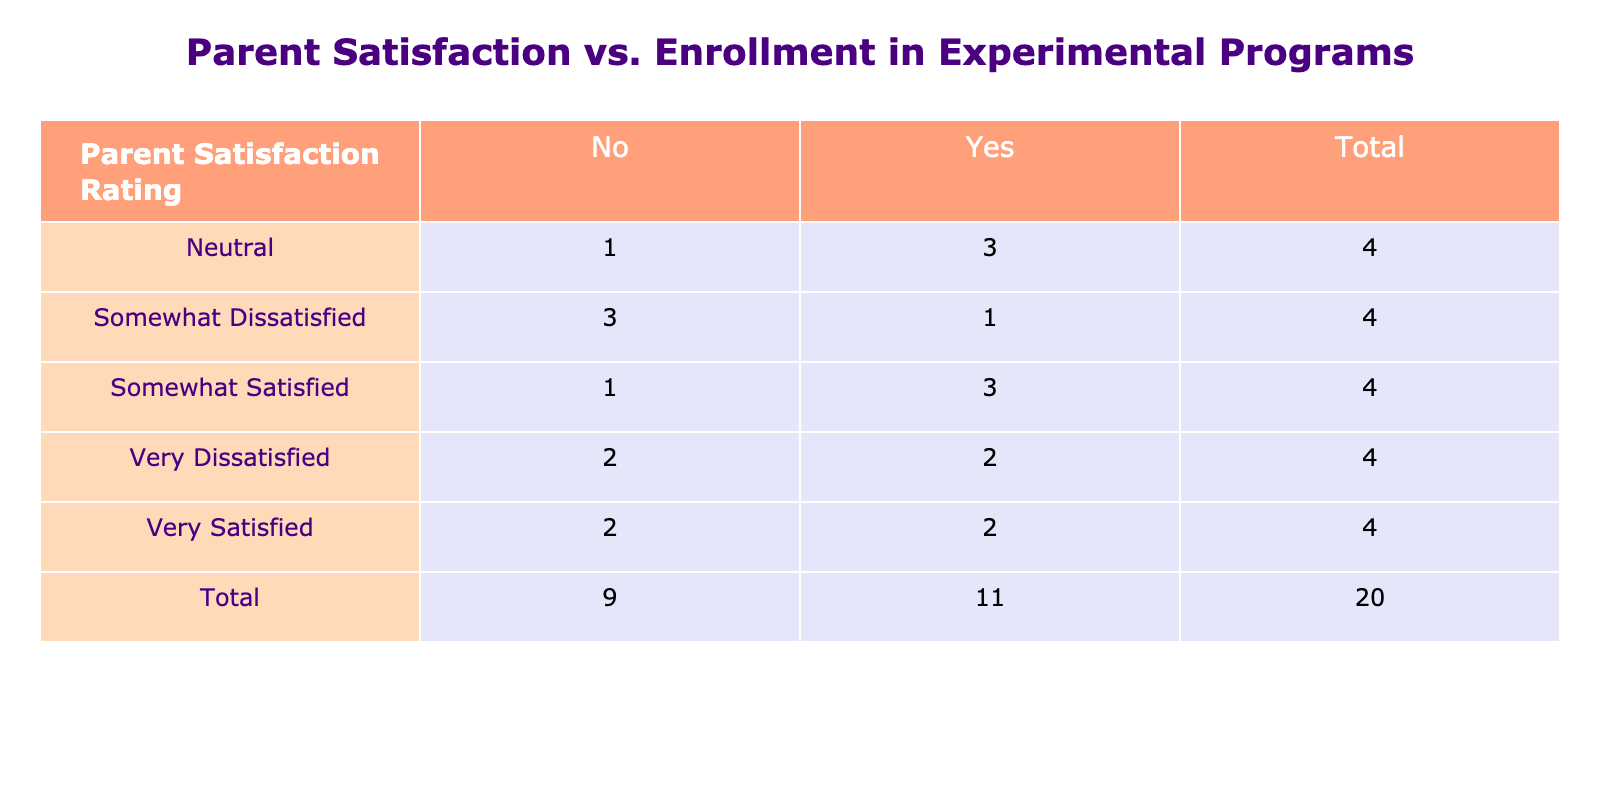What is the total number of parents that were very satisfied with their child's education in experimental programs? From the table, we can see that there are 4 parents who reported being "Very Satisfied" with their child's education, 3 of whom are enrolled in the experimental program and 1 who is not. Therefore, the total number of parents who are very satisfied is 4.
Answer: 4 How many parents were somewhat dissatisfied and did not enroll in experimental education programs? Referring to the table, we can find that there are 3 parents who reported being "Somewhat Dissatisfied", and out of these, 2 did not enroll in the experimental program.
Answer: 2 What percentage of parents are very satisfied with their child's education? In the table, there are 4 parents who are very satisfied, and the grand total of parent satisfaction ratings is 20. To find the percentage, we calculate (4/20) * 100 = 20%.
Answer: 20% Is it true that a majority of parents who enrolled in the experimental program reported being satisfied? Looking at the table, we can see that 11 parents enrolled in the experimental program (Sum of "Very Satisfied", "Somewhat Satisfied", "Neutral", and "Somewhat Dissatisfied" when enrolled). Out of these, at least 6 parents are either "Very Satisfied" or "Somewhat Satisfied”. Since 6 out of 11 represents more than half (54.5%), the statement is true.
Answer: Yes How many total parents expressed neutrality about their child's education in experimental programs? The table shows that there are 4 parents who reported being "Neutral”. Out of these, 3 are enrolled in the experimental program and 1 is not. So, the total number of parents expressing neutrality is 4.
Answer: 4 What is the difference in the number of very dissatisfied parents between those enrolled and not enrolled in the experimental program? According to the table, there are 4 parents who reported being "Very Dissatisfied”, with 3 enrolled in the experimental program and 1 not. To find the difference, we subtract the non-enrolled from the enrolled: 3 - 1 = 2.
Answer: 2 What is the total count of parents who are satisfied, encompassing both very satisfied and somewhat satisfied? Referring to the satisfaction ratings, we can add the numbers of parents who are "Very Satisfied" (4) and those who are "Somewhat Satisfied" (6). Thus, the total count of satisfied parents is 4 + 6 = 10.
Answer: 10 How many parents were dissatisfied overall with their child's education? The table lists parents as "Somewhat Dissatisfied" and "Very Dissatisfied." There are 3 somewhat dissatisfied and 4 very dissatisfied parents. Therefore, adding these figures gives us a total of 3 + 4 = 7 dissatisfied parents.
Answer: 7 What proportion of the parents in the experimental program reported neutrality? In the table, there are 6 parents who expressed neutrality and are enrolled in the experimental program out of a total of 11 parents enrolled. To find the proportion: 6/11 = approximately 54.5%.
Answer: Approximately 54.5% 